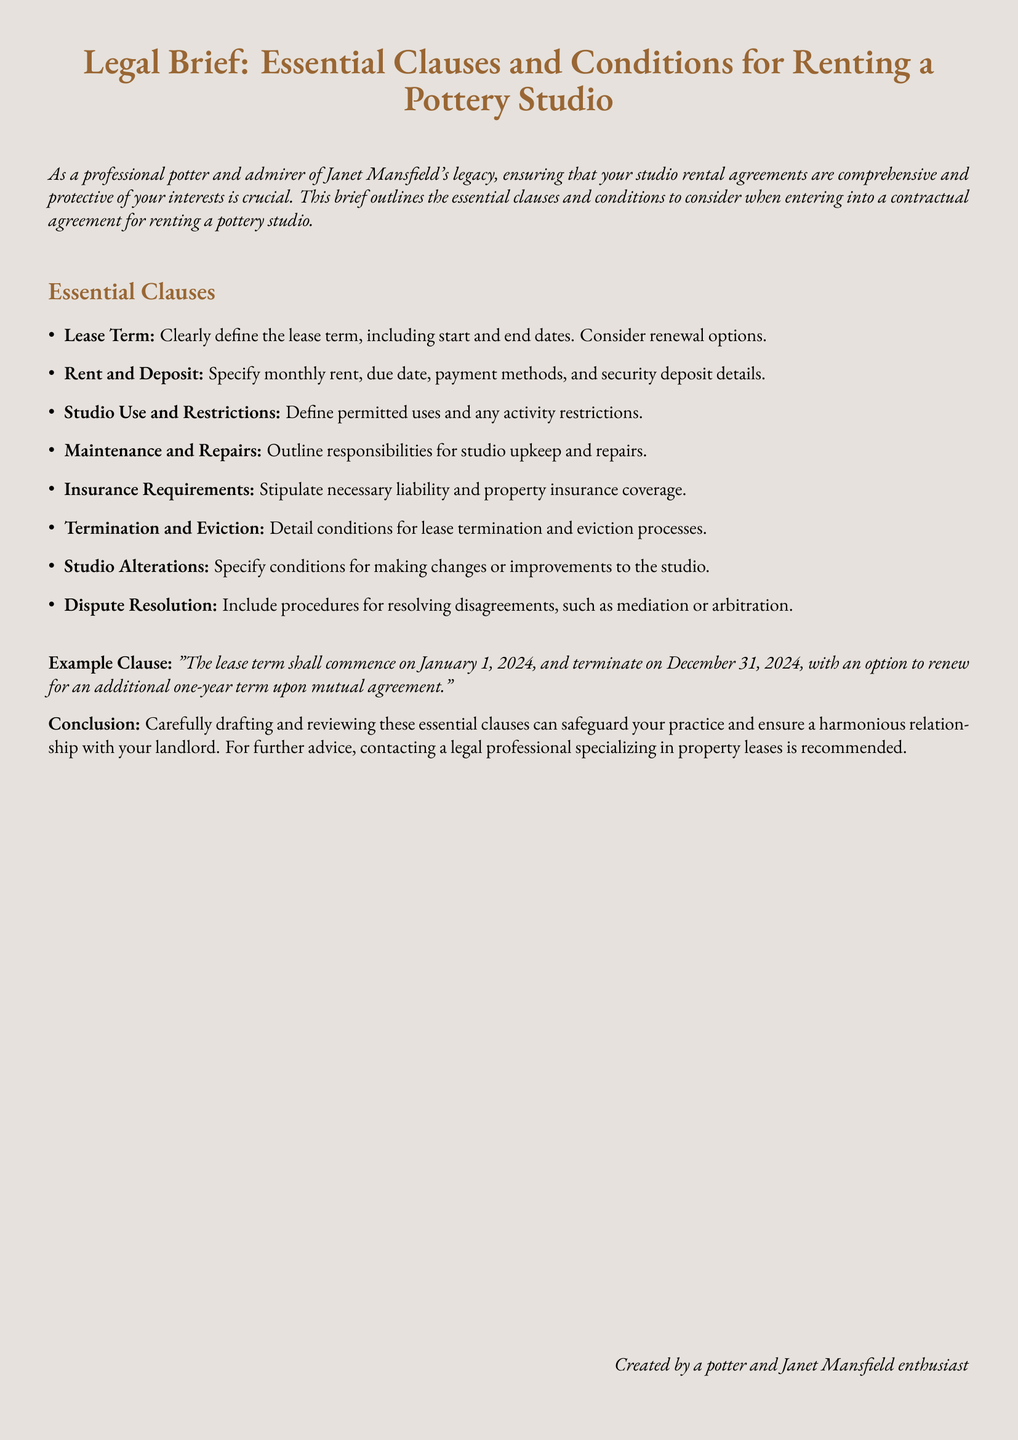What is the lease term start date? The start date of the lease term is explicitly stated in the document as the date on which the lease will commence.
Answer: January 1, 2024 What is the rental payment due date? The document specifies the payment due date related to the monthly rent, which is necessary for financial arrangements.
Answer: Not specified What clause outlines the responsibilities for studio upkeep? This clause is included in the document, detailing the obligations of both parties regarding maintenance.
Answer: Maintenance and Repairs What is the purpose of the Insurance Requirements clause? This clause indicates the necessity for certain types of insurance to protect against potential risks associated with studio use.
Answer: Liability and property insurance coverage What is included in the termination process? The conditions surrounding the end of the lease and eviction are addressed in this section, requiring careful consideration.
Answer: Termination and Eviction What options are available for dispute resolution? The document refers to specific methods to manage disagreements between the renter and landlord, which is crucial for maintaining peace.
Answer: Mediation or arbitration How long is the initial lease term? The document specifies the duration of the lease term outlined in one of the essential clauses.
Answer: One year What is the significance of clearly defining studio use and restrictions? This clause helps in avoiding misunderstandings related to how the studio can be utilized, ensuring compliance with agreed terms.
Answer: Defines permitted uses and any activity restrictions What should be considered when altering the studio? The document states conditions related to making changes or improvements to the rented space, ensuring prior consent and specification.
Answer: Studio Alterations 